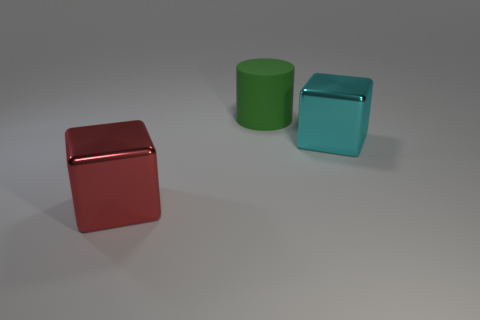Is there anything else that has the same material as the cylinder?
Offer a terse response. No. How many other objects are the same color as the rubber object?
Provide a short and direct response. 0. Are there more things that are to the right of the rubber cylinder than green metallic spheres?
Make the answer very short. Yes. What is the color of the big thing that is in front of the big shiny thing behind the block that is on the left side of the large green rubber object?
Give a very brief answer. Red. Is the material of the big cylinder the same as the big red object?
Offer a terse response. No. Is there a green cylinder of the same size as the red metal cube?
Ensure brevity in your answer.  Yes. There is a green cylinder that is the same size as the red metallic block; what is its material?
Offer a very short reply. Rubber. Is there another large red object that has the same shape as the large red object?
Offer a terse response. No. What is the shape of the metal thing that is in front of the large cyan thing?
Ensure brevity in your answer.  Cube. What number of tiny purple rubber objects are there?
Your response must be concise. 0. 